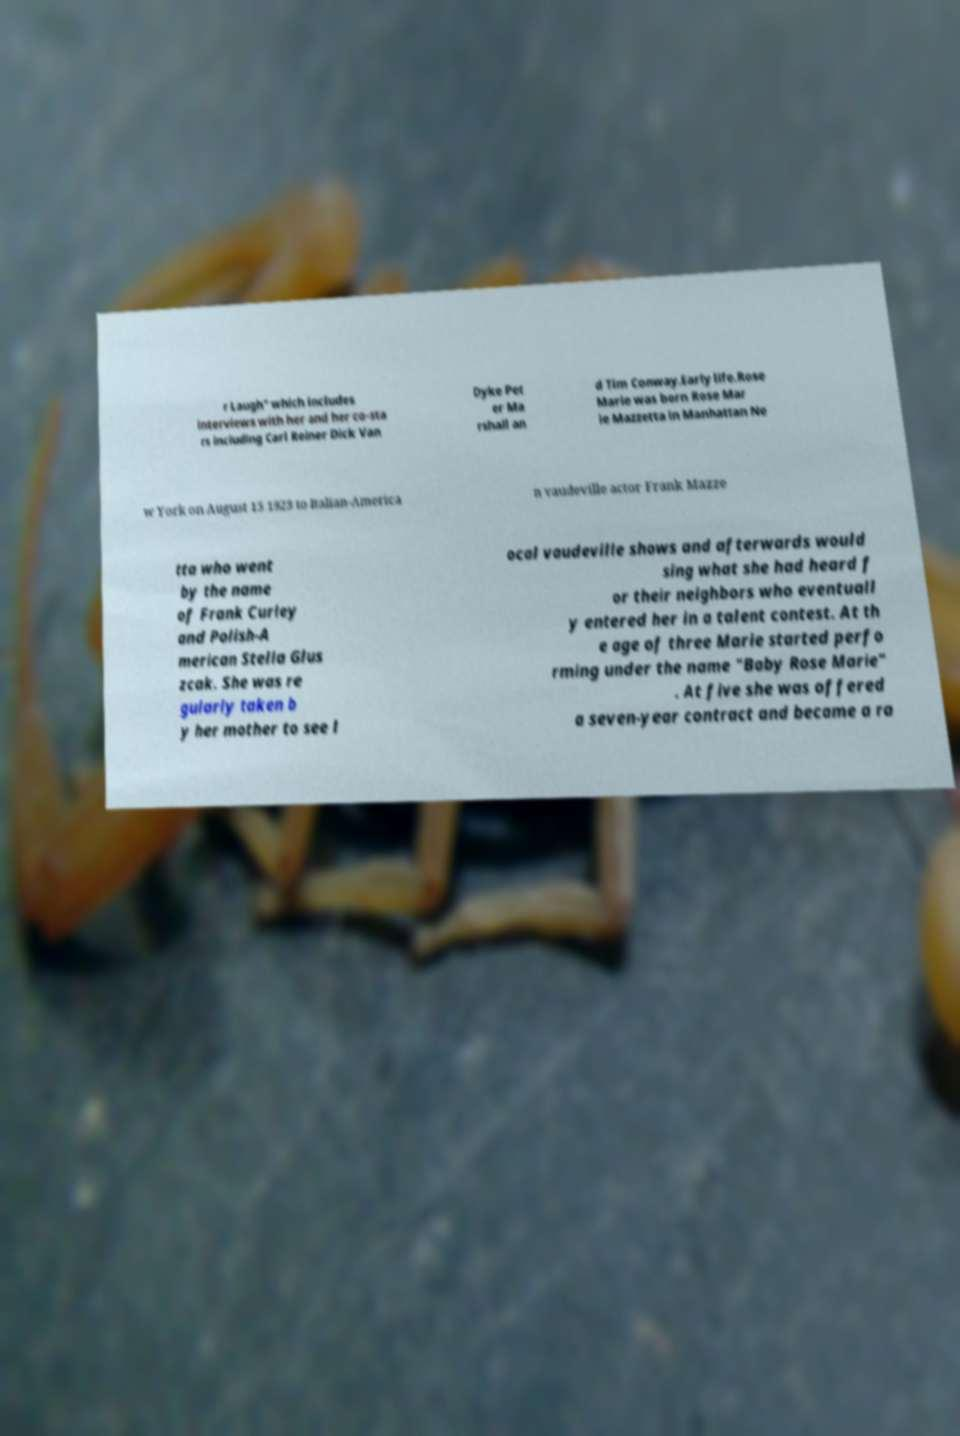There's text embedded in this image that I need extracted. Can you transcribe it verbatim? r Laugh" which includes interviews with her and her co-sta rs including Carl Reiner Dick Van Dyke Pet er Ma rshall an d Tim Conway.Early life.Rose Marie was born Rose Mar ie Mazzetta in Manhattan Ne w York on August 15 1923 to Italian-America n vaudeville actor Frank Mazze tta who went by the name of Frank Curley and Polish-A merican Stella Glus zcak. She was re gularly taken b y her mother to see l ocal vaudeville shows and afterwards would sing what she had heard f or their neighbors who eventuall y entered her in a talent contest. At th e age of three Marie started perfo rming under the name "Baby Rose Marie" . At five she was offered a seven-year contract and became a ra 